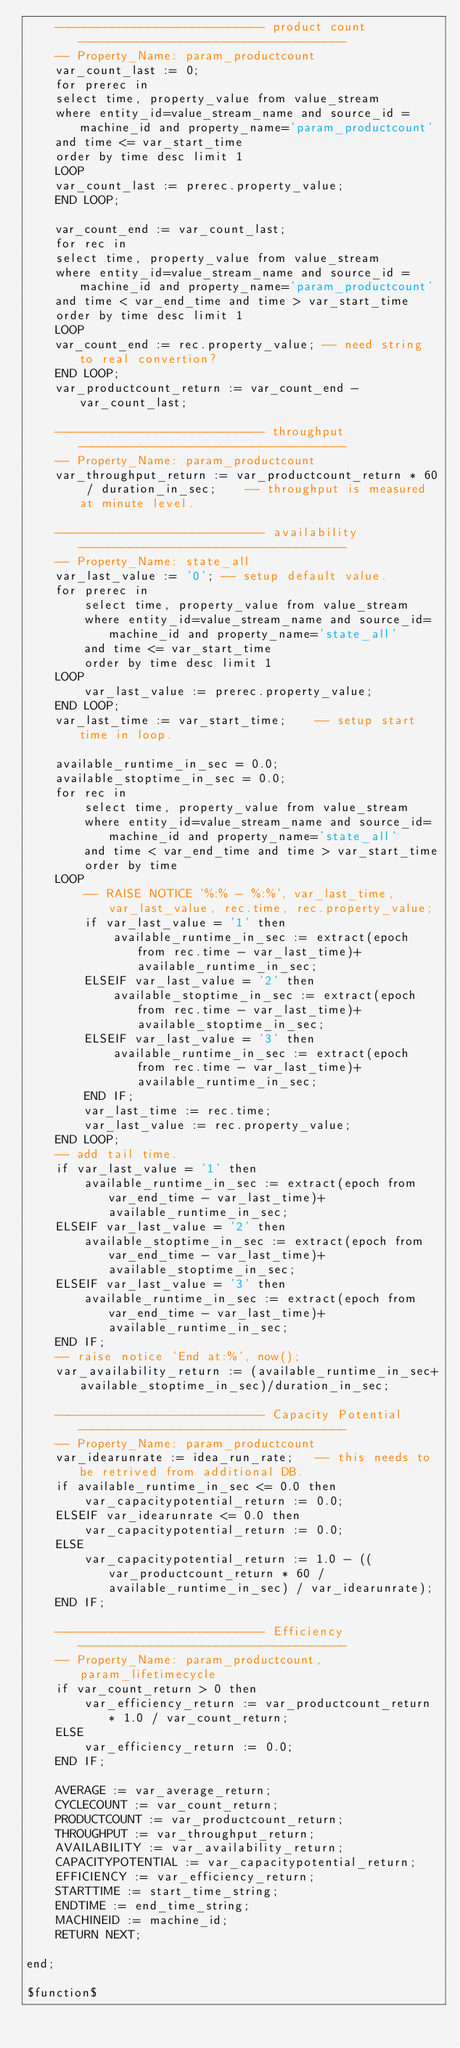Convert code to text. <code><loc_0><loc_0><loc_500><loc_500><_SQL_>	----------------------------- product count -------------------------------------
	-- Property_Name: param_productcount
	var_count_last := 0;
	for prerec in 
	select time, property_value from value_stream
	where entity_id=value_stream_name and source_id = machine_id and property_name='param_productcount'
	and time <= var_start_time
	order by time desc limit 1
	LOOP
	var_count_last := prerec.property_value;
	END LOOP;

	var_count_end := var_count_last;
	for rec in 
	select time, property_value from value_stream
	where entity_id=value_stream_name and source_id = machine_id and property_name='param_productcount'
	and time < var_end_time and time > var_start_time
	order by time desc limit 1
	LOOP
	var_count_end := rec.property_value; -- need string to real convertion?
	END LOOP;
	var_productcount_return := var_count_end - var_count_last;

	----------------------------- throughput -------------------------------------
	-- Property_Name: param_productcount
	var_throughput_return := var_productcount_return * 60 / duration_in_sec;	-- throughput is measured at minute level.

	----------------------------- availability -------------------------------------
	-- Property_Name: state_all
	var_last_value := '0'; -- setup default value.
	for prerec in
		select time, property_value from value_stream 
		where entity_id=value_stream_name and source_id=machine_id and property_name='state_all'
		and time <= var_start_time
		order by time desc limit 1
	LOOP
		var_last_value := prerec.property_value;
	END LOOP;
	var_last_time := var_start_time;	-- setup start time in loop.

	available_runtime_in_sec = 0.0;
	available_stoptime_in_sec = 0.0;
	for rec in 
		select time, property_value from value_stream 
		where entity_id=value_stream_name and source_id=machine_id and property_name='state_all'
		and time < var_end_time and time > var_start_time
		order by time
	LOOP
		-- RAISE NOTICE '%:% - %:%', var_last_time, var_last_value, rec.time, rec.property_value;
		if var_last_value = '1' then
			available_runtime_in_sec := extract(epoch from rec.time - var_last_time)+ available_runtime_in_sec;
		ELSEIF var_last_value = '2' then
			available_stoptime_in_sec := extract(epoch from rec.time - var_last_time)+ available_stoptime_in_sec;
		ELSEIF var_last_value = '3' then
			available_runtime_in_sec := extract(epoch from rec.time - var_last_time)+ available_runtime_in_sec;
		END IF;
		var_last_time := rec.time;
		var_last_value := rec.property_value;
	END LOOP;
	-- add tail time.
	if var_last_value = '1' then
		available_runtime_in_sec := extract(epoch from var_end_time - var_last_time)+ available_runtime_in_sec;
	ELSEIF var_last_value = '2' then
		available_stoptime_in_sec := extract(epoch from var_end_time - var_last_time)+ available_stoptime_in_sec;
	ELSEIF var_last_value = '3' then
		available_runtime_in_sec := extract(epoch from var_end_time - var_last_time)+ available_runtime_in_sec;
	END IF;
	-- raise notice 'End at:%', now();
	var_availability_return := (available_runtime_in_sec+available_stoptime_in_sec)/duration_in_sec;
	
	----------------------------- Capacity Potential -------------------------------------
	-- Property_Name: param_productcount
	var_idearunrate := idea_run_rate;	-- this needs to be retrived from additional DB.
	if available_runtime_in_sec <= 0.0 then
		var_capacitypotential_return := 0.0;
	ELSEIF var_idearunrate <= 0.0 then
		var_capacitypotential_return := 0.0;
	ELSE
		var_capacitypotential_return := 1.0 - ((var_productcount_return * 60 /available_runtime_in_sec) / var_idearunrate);
	END IF;
	
	----------------------------- Efficiency -------------------------------------
	-- Property_Name: param_productcount, param_lifetimecycle
	if var_count_return > 0 then
		var_efficiency_return := var_productcount_return * 1.0 / var_count_return;
	ELSE
		var_efficiency_return := 0.0;
	END IF;

	AVERAGE := var_average_return;
	CYCLECOUNT := var_count_return;
	PRODUCTCOUNT := var_productcount_return;
	THROUGHPUT := var_throughput_return;
	AVAILABILITY := var_availability_return;
	CAPACITYPOTENTIAL := var_capacitypotential_return;
	EFFICIENCY := var_efficiency_return;
	STARTTIME := start_time_string;
	ENDTIME := end_time_string;
	MACHINEID := machine_id;
	RETURN NEXT;

end;

$function$
</code> 